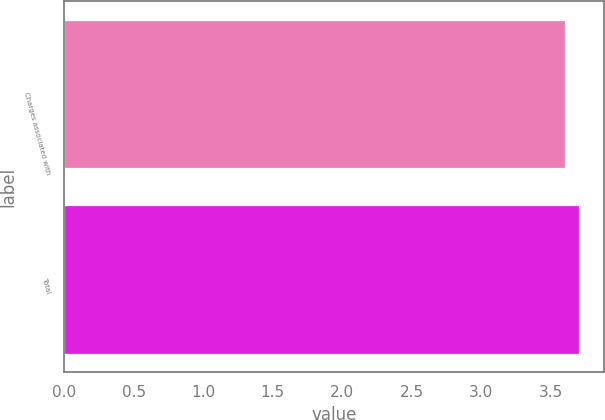<chart> <loc_0><loc_0><loc_500><loc_500><bar_chart><fcel>Charges associated with<fcel>Total<nl><fcel>3.6<fcel>3.7<nl></chart> 